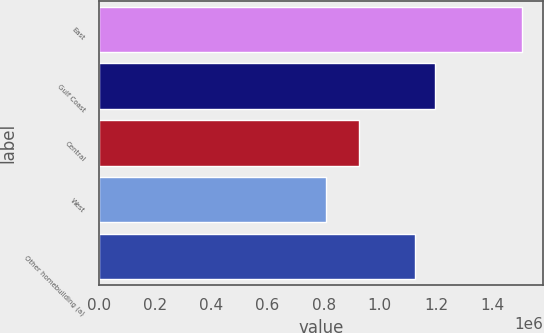<chart> <loc_0><loc_0><loc_500><loc_500><bar_chart><fcel>East<fcel>Gulf Coast<fcel>Central<fcel>West<fcel>Other homebuilding (a)<nl><fcel>1.50679e+06<fcel>1.19692e+06<fcel>925285<fcel>809318<fcel>1.12717e+06<nl></chart> 